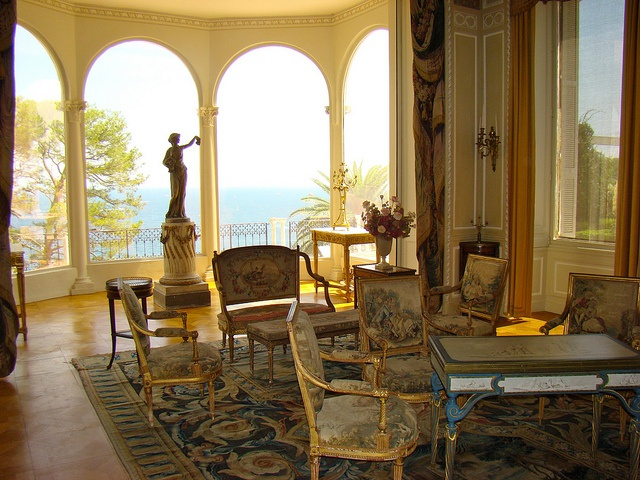Describe the objects in this image and their specific colors. I can see dining table in black, olive, gray, and maroon tones, chair in black, olive, and gray tones, chair in black, maroon, and tan tones, chair in black, olive, and maroon tones, and chair in black, olive, and maroon tones in this image. 